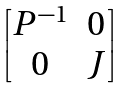<formula> <loc_0><loc_0><loc_500><loc_500>\begin{bmatrix} P ^ { - 1 } & 0 \\ 0 & J \end{bmatrix}</formula> 